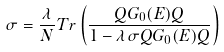<formula> <loc_0><loc_0><loc_500><loc_500>\sigma = \frac { \lambda } { N } T r \left ( \frac { Q G _ { 0 } ( E ) Q } { 1 - \lambda \sigma Q G _ { 0 } ( E ) Q } \right )</formula> 